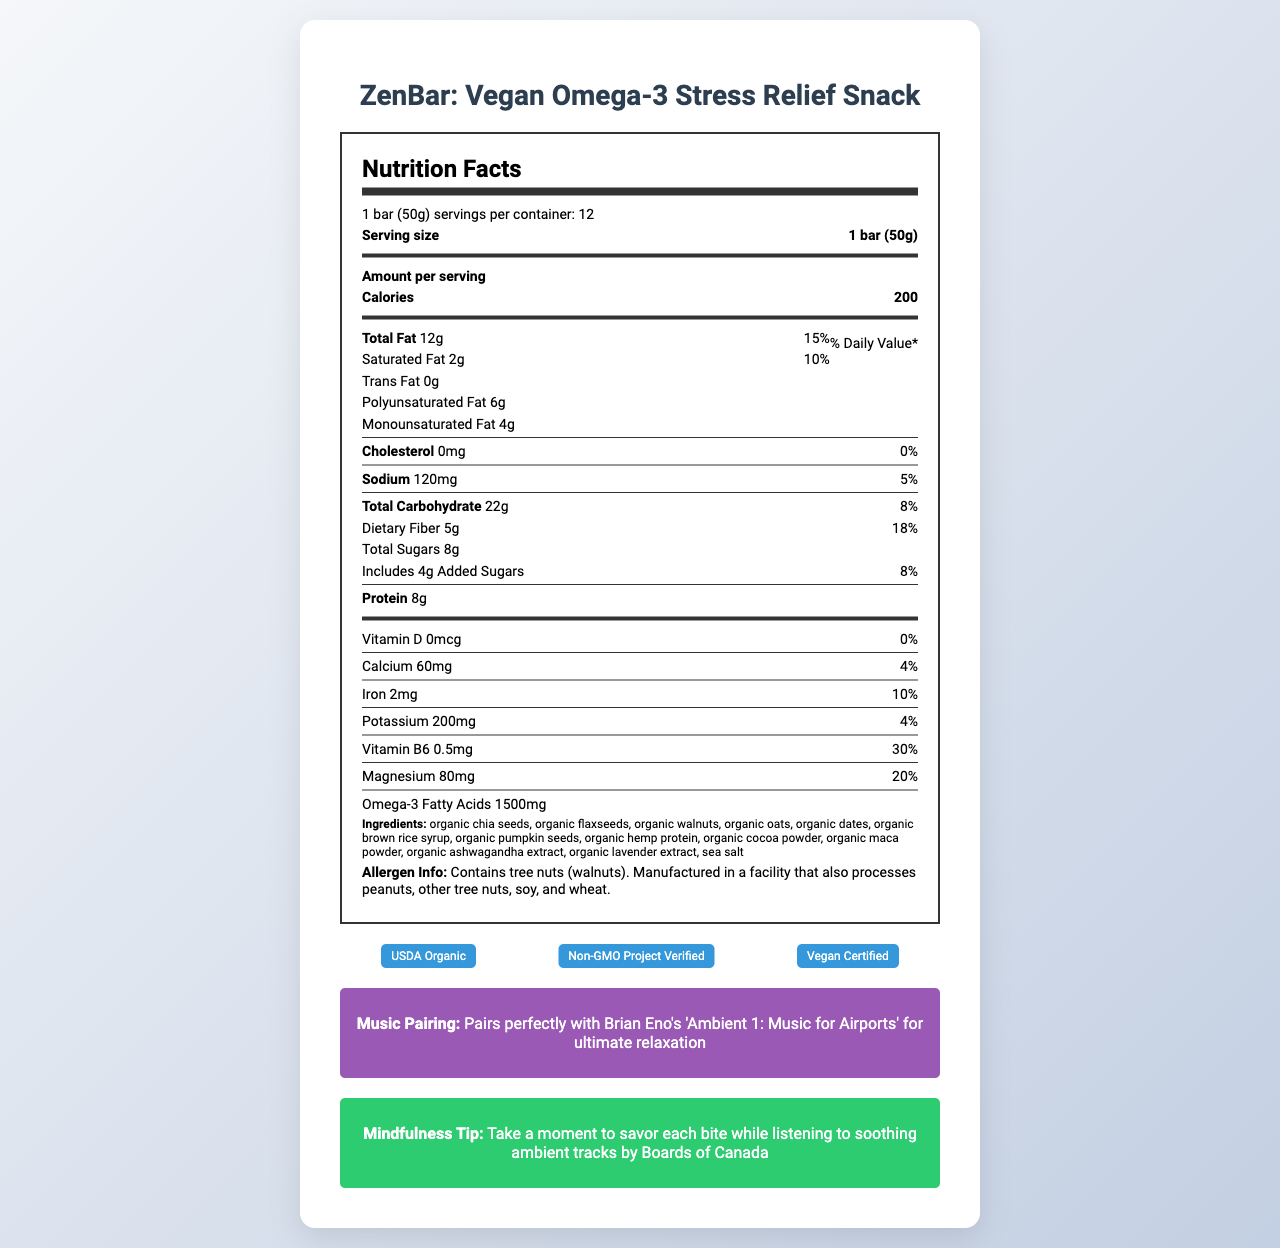what is the serving size of the ZenBar? The Nutrition Facts Label clearly states that the serving size is "1 bar (50g)".
Answer: 1 bar (50g) how many servings are there per container? The document mentions that there are "12" servings per container.
Answer: 12 how much saturated fat does each bar contain? The label lists "Saturated Fat 2g" under the fat section.
Answer: 2g what percentage of the daily value for magnesium does each bar provide? The Nutrition Facts lists "Magnesium 80mg" which corresponds to a daily value of "20%".
Answer: 20% what is the total carbohydrate content per serving? The label indicates that the "Total Carbohydrate" content is "22g".
Answer: 22g which ingredient contributes to the vegan and omega-3 rich profile of ZenBar? A. Organic oats B. Organic chia seeds C. Organic dates D. Organic cocoa powder Organic chia seeds are known for their high omega-3 content and contribute to the vegan profile.
Answer: B which of the following marketing claims does not apply to the ZenBar? A. Gluten-free B. Contains dairy C. Plant-based protein D. No artificial ingredients The document does not mention dairy; it is a vegan product, making option B incorrect.
Answer: B does the ZenBar contain any trans fat? The label specifies "Trans Fat 0g," indicating no trans fat.
Answer: No summarize the main idea of the document. The document outlines the nutritional facts, ingredients, certifications, and marketing claims of the ZenBar, emphasizing its health benefits and suitability for relaxation.
Answer: ZenBar is a vegan, omega-3 rich snack bar designed for stress relief, containing various organic ingredients. It is noted for its nutrition benefits, including high fiber and protein content, and features several certifications like USDA Organic, Non-GMO Project Verified, and Vegan Certified. The document also highlights its pairing with ambient music for a relaxing experience. what is the exact amount of potassium per serving? The label lists "Potassium 200mg" clearly in the mineral section.
Answer: 200mg what are the main ingredients that are used for stress relief in ZenBar? The stress-relieving herbs in the ingredients list are organic maca powder, organic ashwagandha extract, and organic lavender extract.
Answer: organic maca powder, organic ashwagandha extract, organic lavender extract how many total calories are in one ZenBar? The Nutrition Facts label states that each bar contains "200" calories.
Answer: 200 what is the allergen information provided for ZenBar? The allergen info section of the document provides this detailed information.
Answer: Contains tree nuts (walnuts). Manufactured in a facility that also processes peanuts, other tree nuts, soy, and wheat. is ZenBar certified as Non-GMO? One of the listed certifications is "Non-GMO Project Verified".
Answer: Yes how much Vitamin D is in ZenBar? The nutrition label lists "Vitamin D 0mcg" and "0%" daily value.
Answer: 0mcg who is the recommended musician for pairing with ZenBar for relaxation? The music pairing section of the document suggests Brian Eno's 'Ambient 1: Music for Airports' for relaxation.
Answer: Brian Eno how much added sugar is in one serving of ZenBar? The label shows "Includes 4g Added Sugars," with a daily value of "8%".
Answer: 4g what type of protein is used in ZenBar? The marketing claims include "Plant-based protein."
Answer: Plant-based protein is ZenBar considered organic? The ZenBar has the "USDA Organic" certification, indicating it is organic.
Answer: Yes what is the recommended mindfulness tip when consuming ZenBar? The document lists this mindfulness tip in a dedicated section.
Answer: Take a moment to savor each bite while listening to soothing ambient tracks by Boards of Canada 